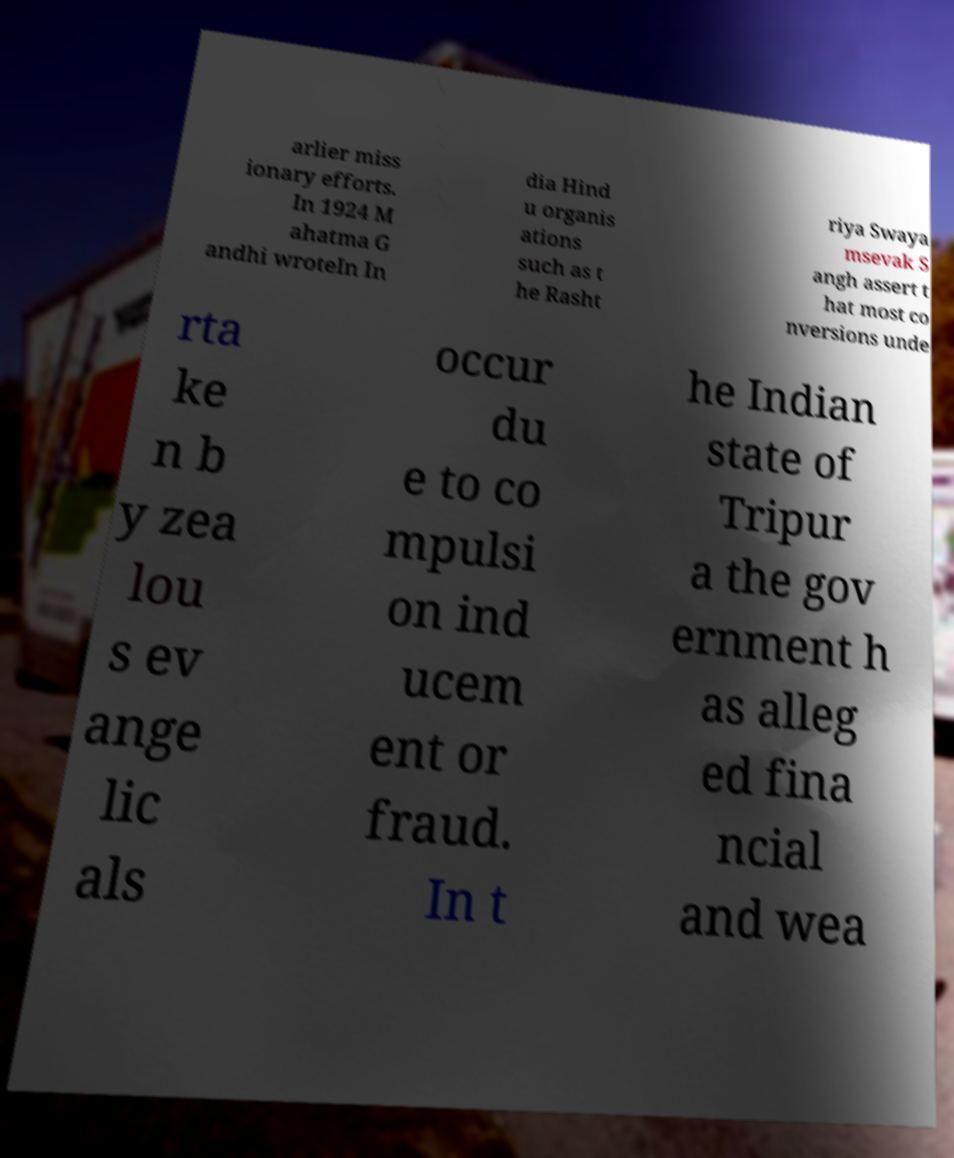There's text embedded in this image that I need extracted. Can you transcribe it verbatim? arlier miss ionary efforts. In 1924 M ahatma G andhi wroteIn In dia Hind u organis ations such as t he Rasht riya Swaya msevak S angh assert t hat most co nversions unde rta ke n b y zea lou s ev ange lic als occur du e to co mpulsi on ind ucem ent or fraud. In t he Indian state of Tripur a the gov ernment h as alleg ed fina ncial and wea 